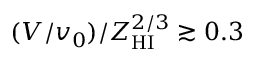<formula> <loc_0><loc_0><loc_500><loc_500>( V / v _ { 0 } ) / Z _ { H I } ^ { 2 / 3 } \gtrsim 0 . 3</formula> 